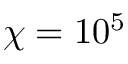Convert formula to latex. <formula><loc_0><loc_0><loc_500><loc_500>\chi = 1 0 ^ { 5 }</formula> 